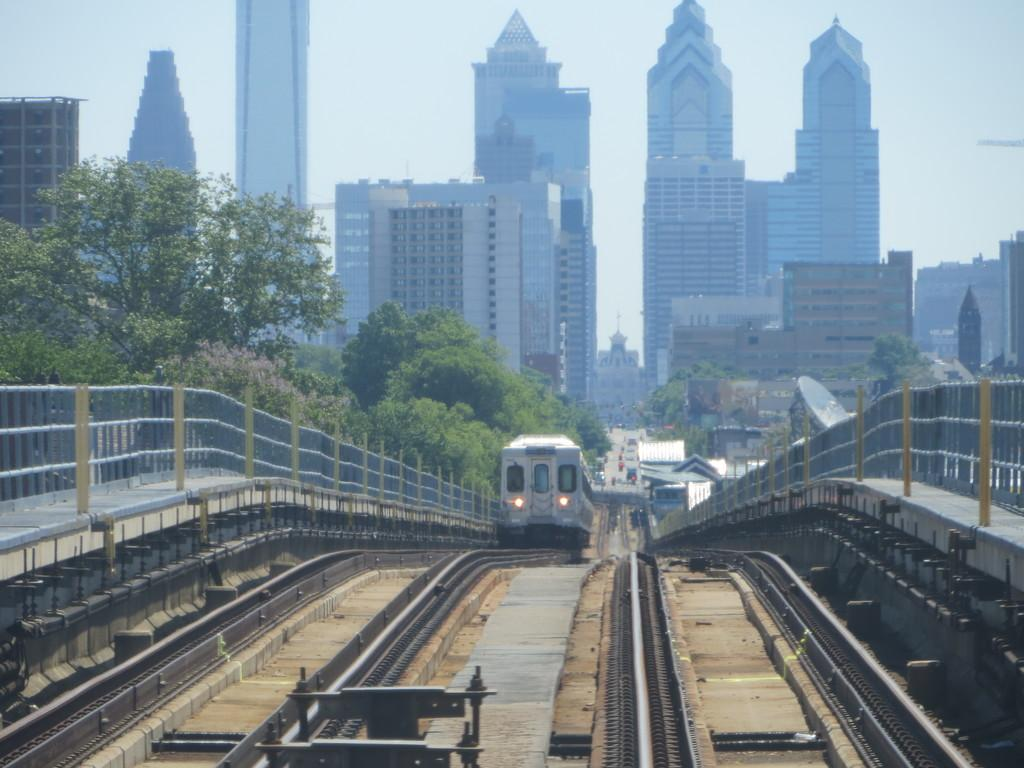What is the main subject of the image? The main subject of the image is a train on the track. What other objects can be seen in the image? There is a fence, trees, buildings, vehicles on the road, and the sky is visible in the background of the image. Can you describe the setting of the image? The image features a train on a track, surrounded by a fence, trees, and buildings. There are also vehicles on the road, indicating a possible urban or suburban setting. What type of hook can be seen holding up the train in the image? There is no hook holding up the train in the image; the train is on a track. How does the train look when it sparks in the image? There is no indication of the train sparking in the image. 